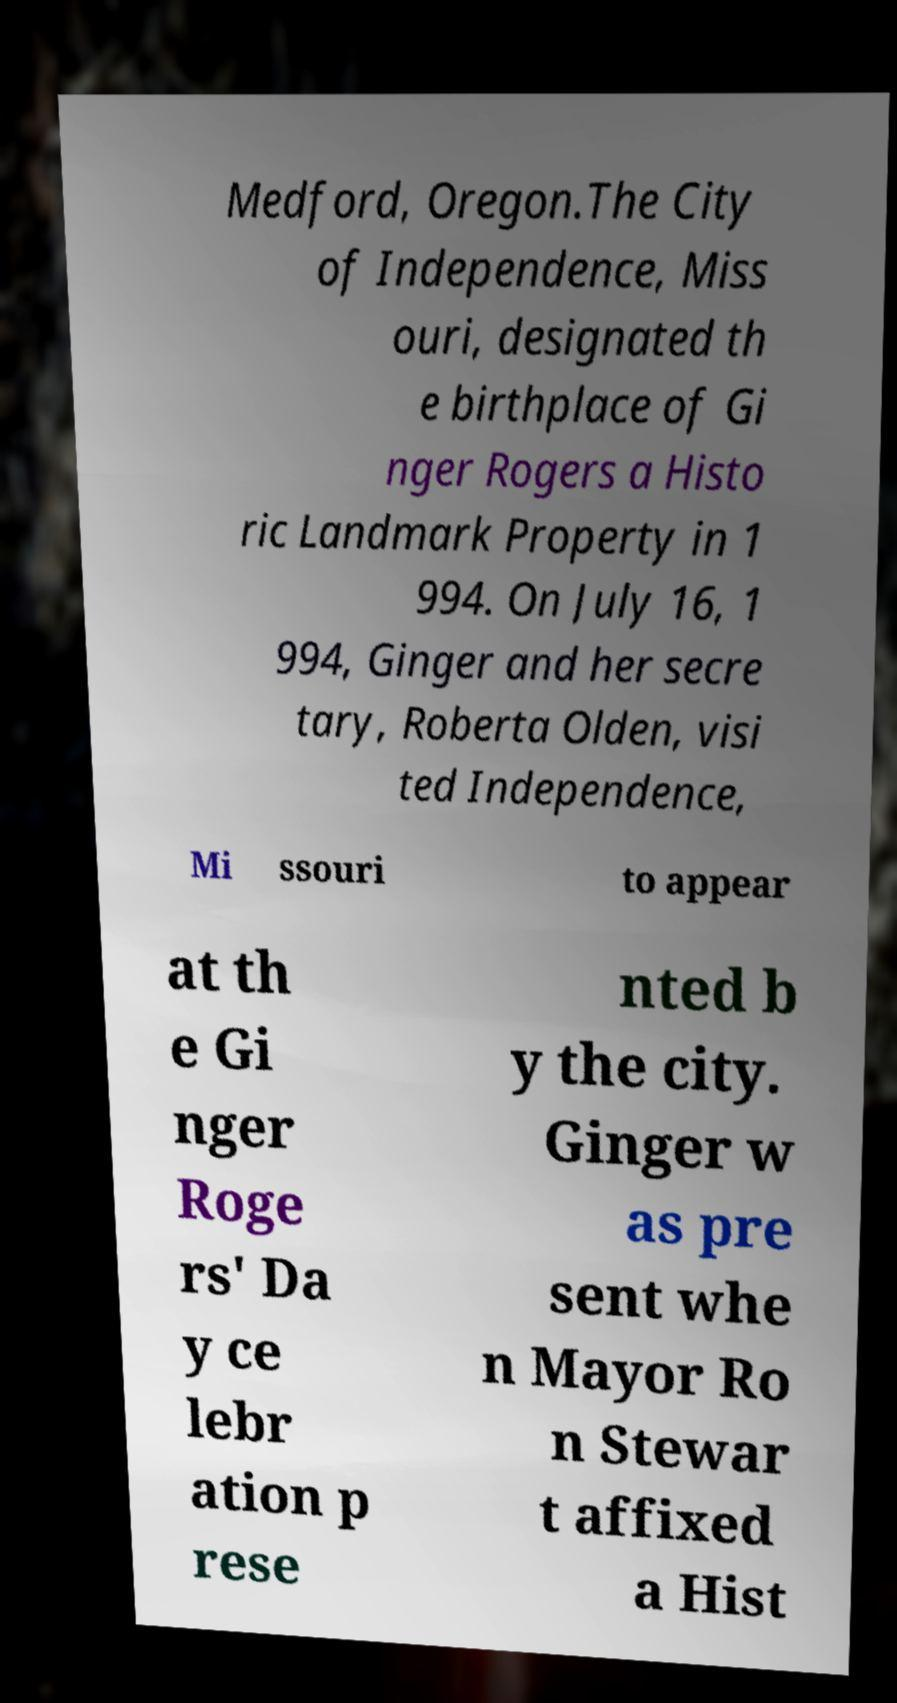For documentation purposes, I need the text within this image transcribed. Could you provide that? Medford, Oregon.The City of Independence, Miss ouri, designated th e birthplace of Gi nger Rogers a Histo ric Landmark Property in 1 994. On July 16, 1 994, Ginger and her secre tary, Roberta Olden, visi ted Independence, Mi ssouri to appear at th e Gi nger Roge rs' Da y ce lebr ation p rese nted b y the city. Ginger w as pre sent whe n Mayor Ro n Stewar t affixed a Hist 